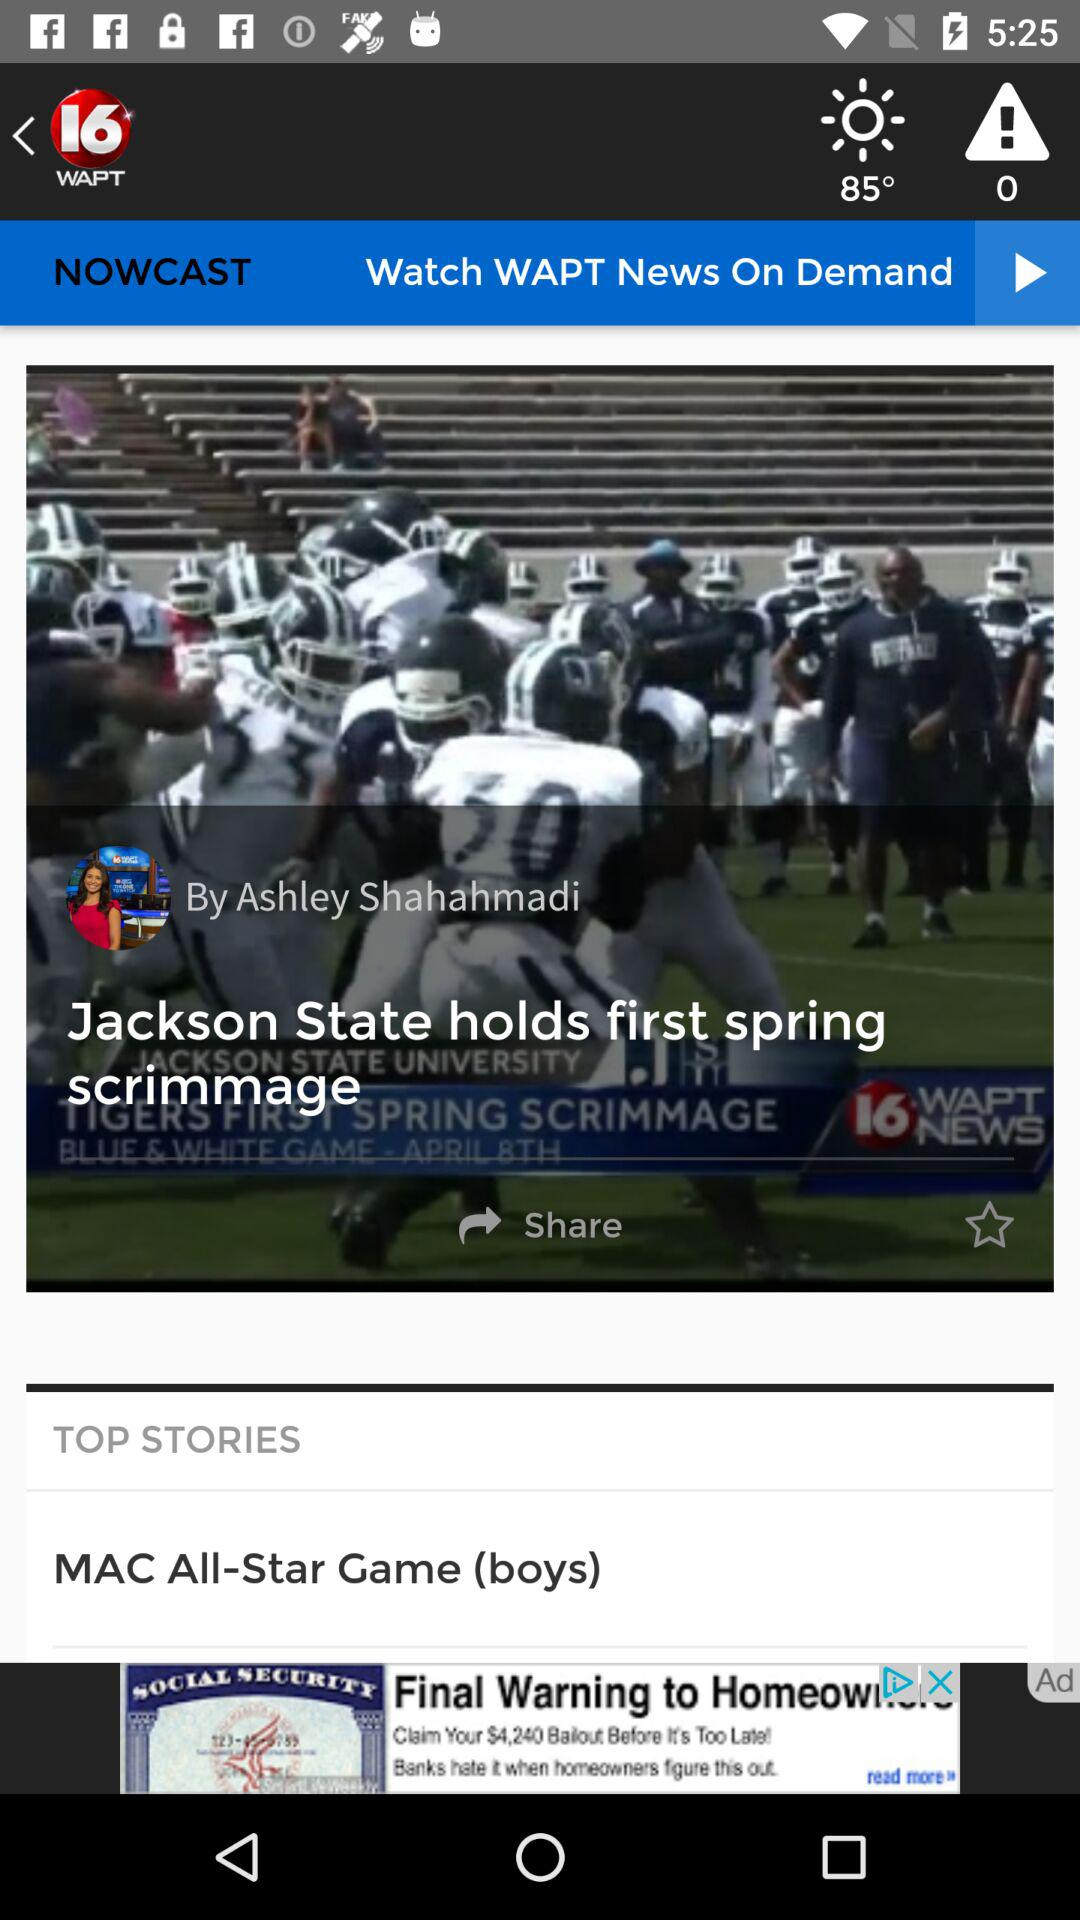What is the time of the news?
When the provided information is insufficient, respond with <no answer>. <no answer> 